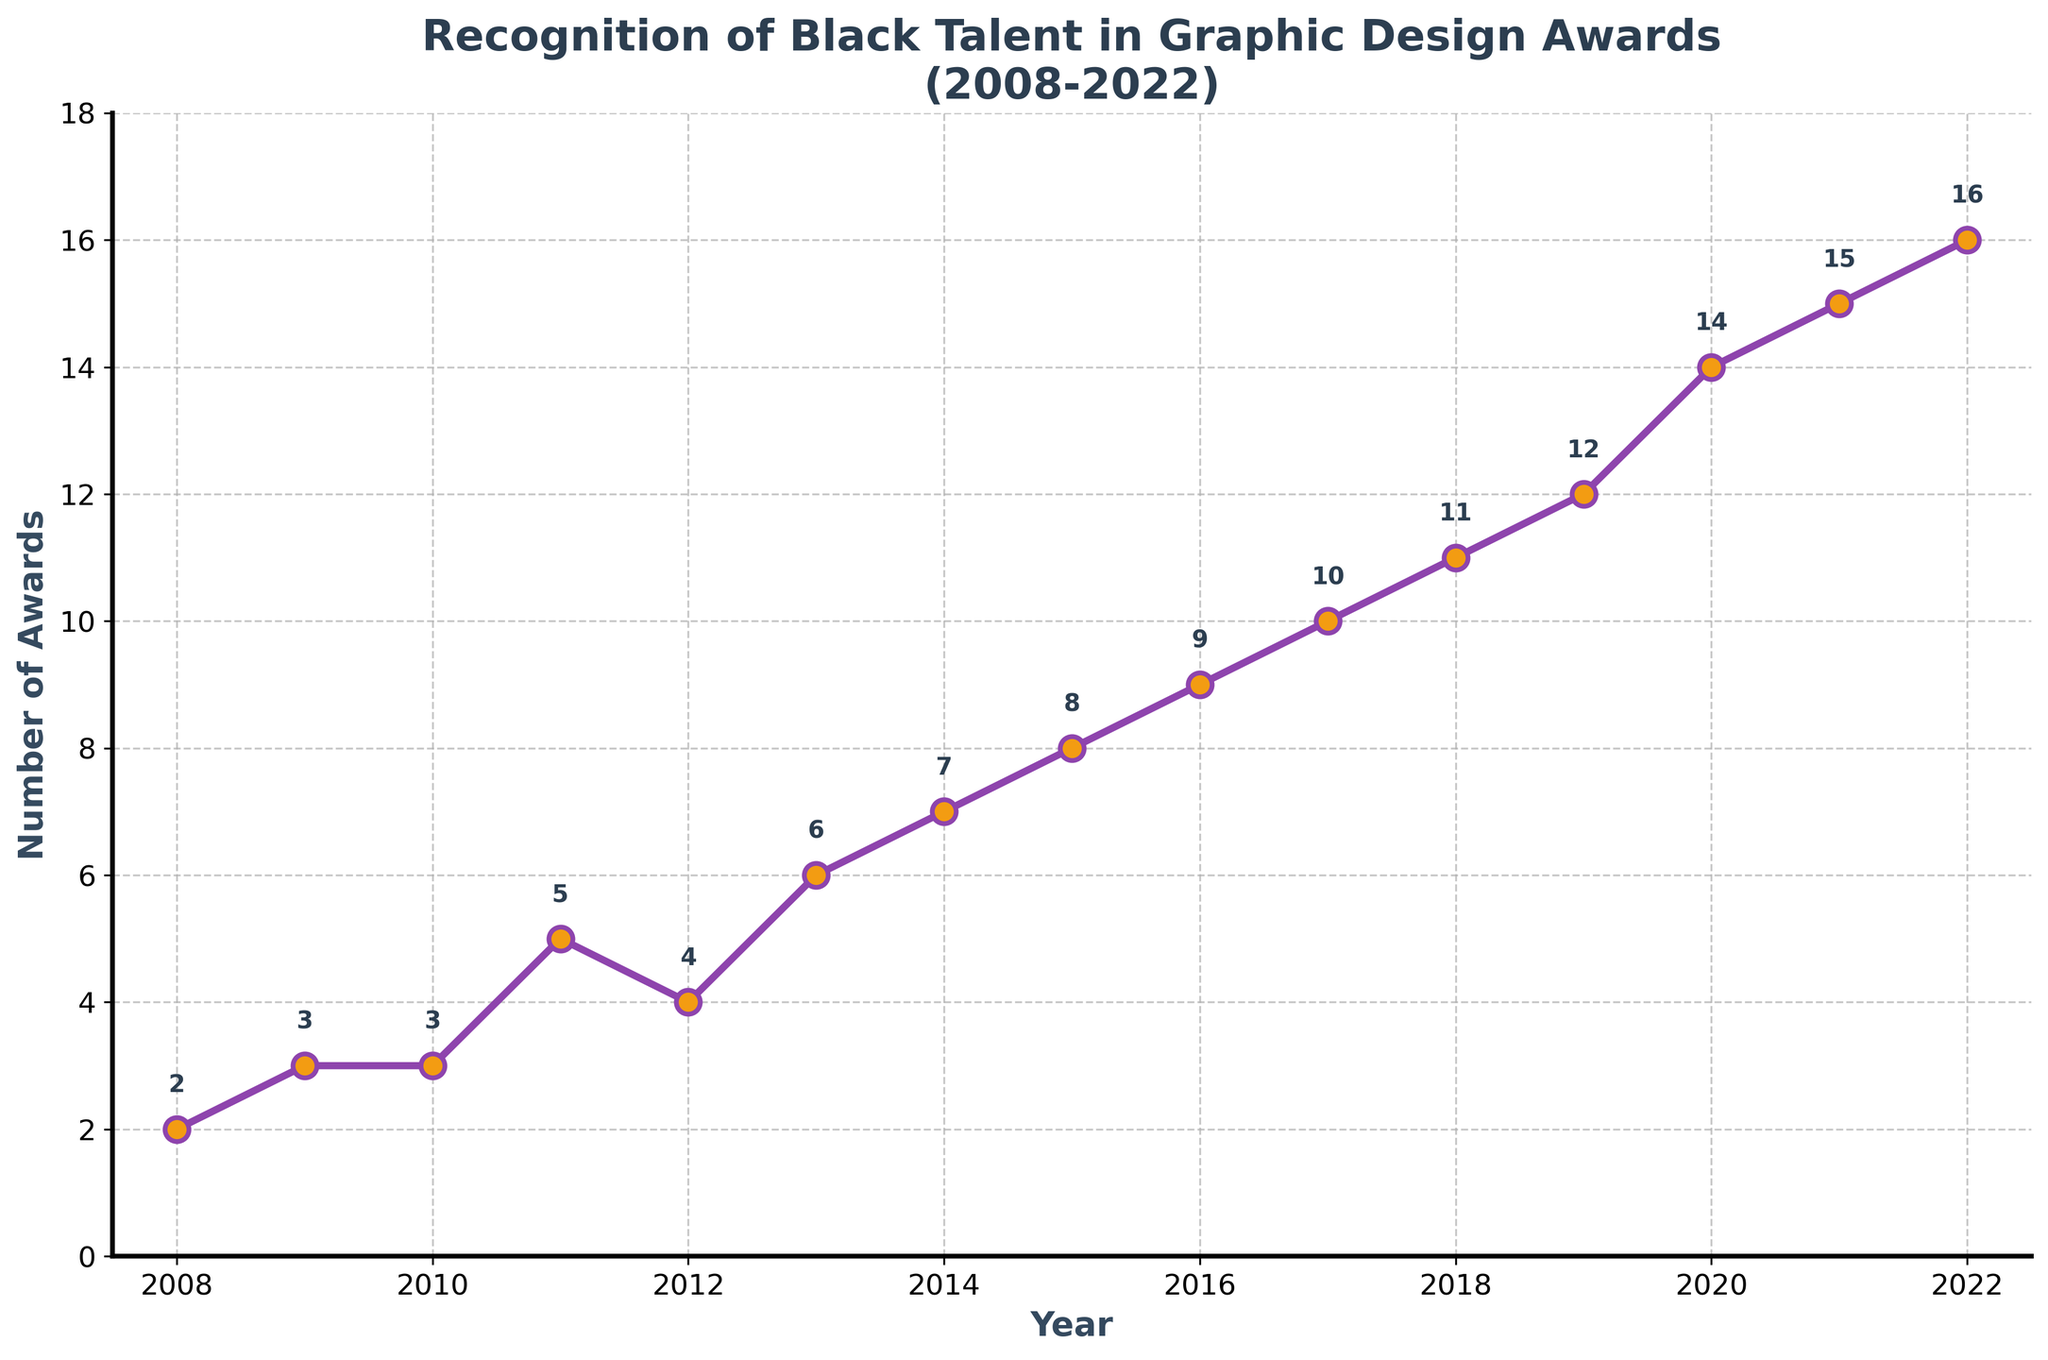What is the title of the plot? The title of the plot is displayed at the top of the figure. Look for the text in a larger or bold font which usually indicates the title.
Answer: Recognition of Black Talent in Graphic Design Awards (2008-2022) How many awards recognized Black talent in 2010? Locate the year 2010 on the x-axis and find the corresponding data point on the y-axis. The value at this point indicates the number of awards.
Answer: 3 What is the trend in the number of awards recognizing Black talent from 2008 to 2022? Examine the line plot from left to right. Observe whether the number of awards increases, decreases, or stays the same over time.
Answer: Increasing By how many awards did recognition of Black talent increase from 2008 to 2022? Identify the number of awards in 2008 and 2022, then subtract the 2008 value from the 2022 value. The difference gives the increase.
Answer: 14 Which year saw the largest single-year increase in the recognition of Black talent? Look at the distances between data points for consecutive years on the plot. The year with the largest gap between two adjacent points indicates the largest increase.
Answer: 2010 to 2011 or 2018 to 2019 What is the median number of awards recognizing Black talent over the years shown? List all the number of awards from 2008 to 2022, sort them, and find the middle value because there are an odd number of years (15).
Answer: 9 Comparing 2010 and 2020, in which year did more awards recognize Black talent? Locate the data points for 2010 and 2020 on the plot and compare their y-axis values.
Answer: 2020 In which year was the number of awards first greater than 10? Find the earliest year on the x-axis where the y-axis value is greater than 10.
Answer: 2018 What is the average number of awards recognizing Black talent between 2008 and 2022? Sum all the numbers of awards from each year and divide by the number of years (15) to find the average.
Answer: 8.4 